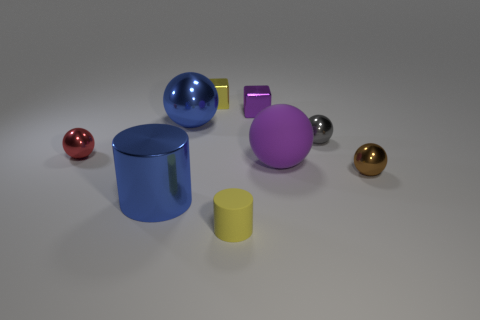There is a cylinder on the right side of the yellow object that is behind the large ball that is to the left of the purple rubber object; how big is it?
Provide a short and direct response. Small. Is the number of large metallic balls that are in front of the large blue shiny sphere less than the number of small shiny objects that are on the left side of the small purple thing?
Your answer should be compact. Yes. How many large blue cylinders are made of the same material as the brown object?
Ensure brevity in your answer.  1. Are there any metallic objects behind the small yellow thing that is behind the blue metal thing in front of the large rubber thing?
Ensure brevity in your answer.  No. What shape is the purple object that is made of the same material as the small yellow block?
Ensure brevity in your answer.  Cube. Are there more yellow cubes than cylinders?
Offer a terse response. No. There is a tiny rubber object; does it have the same shape as the big object in front of the brown ball?
Your answer should be very brief. Yes. What material is the brown thing?
Your response must be concise. Metal. What is the color of the small object in front of the big metal thing in front of the tiny shiny object in front of the tiny red sphere?
Provide a short and direct response. Yellow. There is a brown object that is the same shape as the big purple thing; what is it made of?
Give a very brief answer. Metal. 